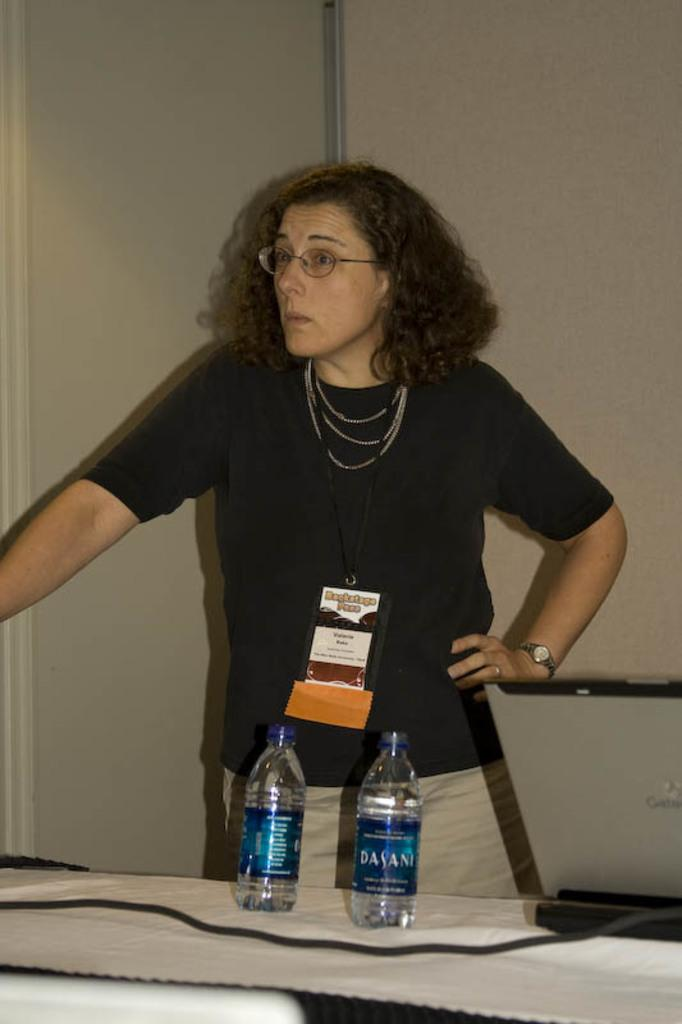Who is the main subject in the image? There is a lady in the image. What is the lady wearing on her face? The lady is wearing specs. What other accessories can be seen on the lady? The lady is wearing chains and a watch. What is the lady's posture in the image? The lady is standing. What is present in front of the lady? There is a table in front of the lady. What can be found on the table? There is a wire and two bottles on the table. What is visible in the background of the image? There is a wall in the background of the image. How many snails are crawling on the wall in the image? There are no snails present in the image; only the lady, her accessories, the table, and the wall are visible. 